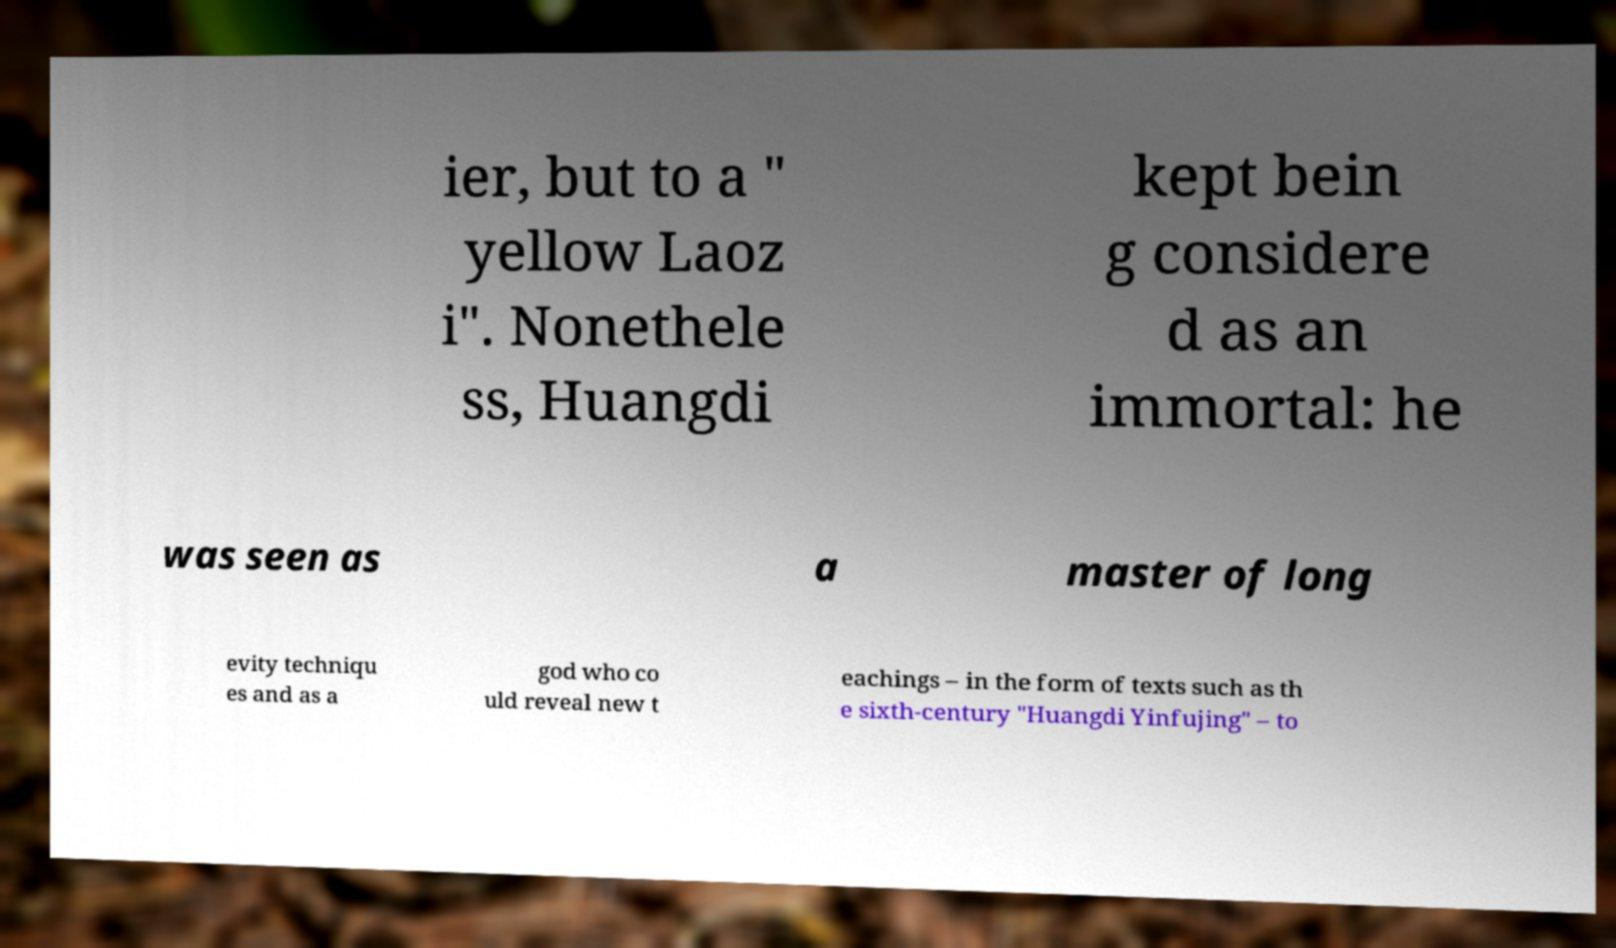What messages or text are displayed in this image? I need them in a readable, typed format. ier, but to a " yellow Laoz i". Nonethele ss, Huangdi kept bein g considere d as an immortal: he was seen as a master of long evity techniqu es and as a god who co uld reveal new t eachings – in the form of texts such as th e sixth-century "Huangdi Yinfujing" – to 